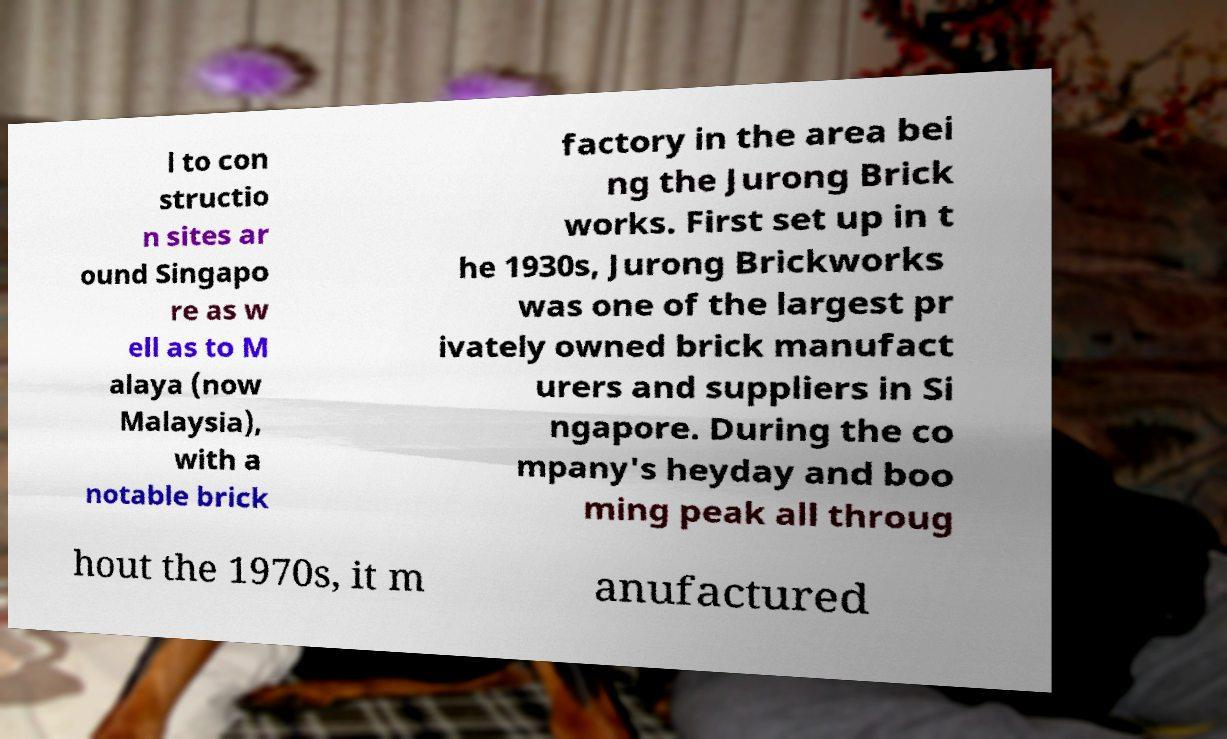For documentation purposes, I need the text within this image transcribed. Could you provide that? l to con structio n sites ar ound Singapo re as w ell as to M alaya (now Malaysia), with a notable brick factory in the area bei ng the Jurong Brick works. First set up in t he 1930s, Jurong Brickworks was one of the largest pr ivately owned brick manufact urers and suppliers in Si ngapore. During the co mpany's heyday and boo ming peak all throug hout the 1970s, it m anufactured 